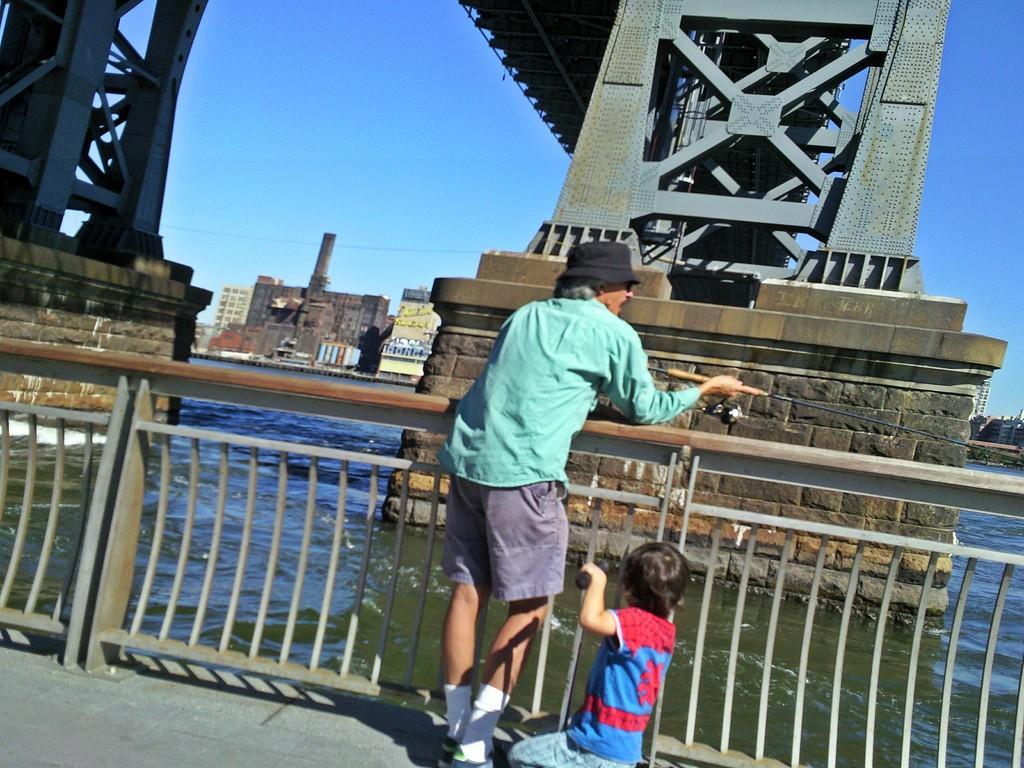How would you summarize this image in a sentence or two? In the center of the image there are two persons, a man is standing and holding an object and a boy is sitting on his knee. In the background of the image we can see a bridge and a buildings, water, grills are present. At the top of the image sky is there. At the bottom of the image ground is present. 